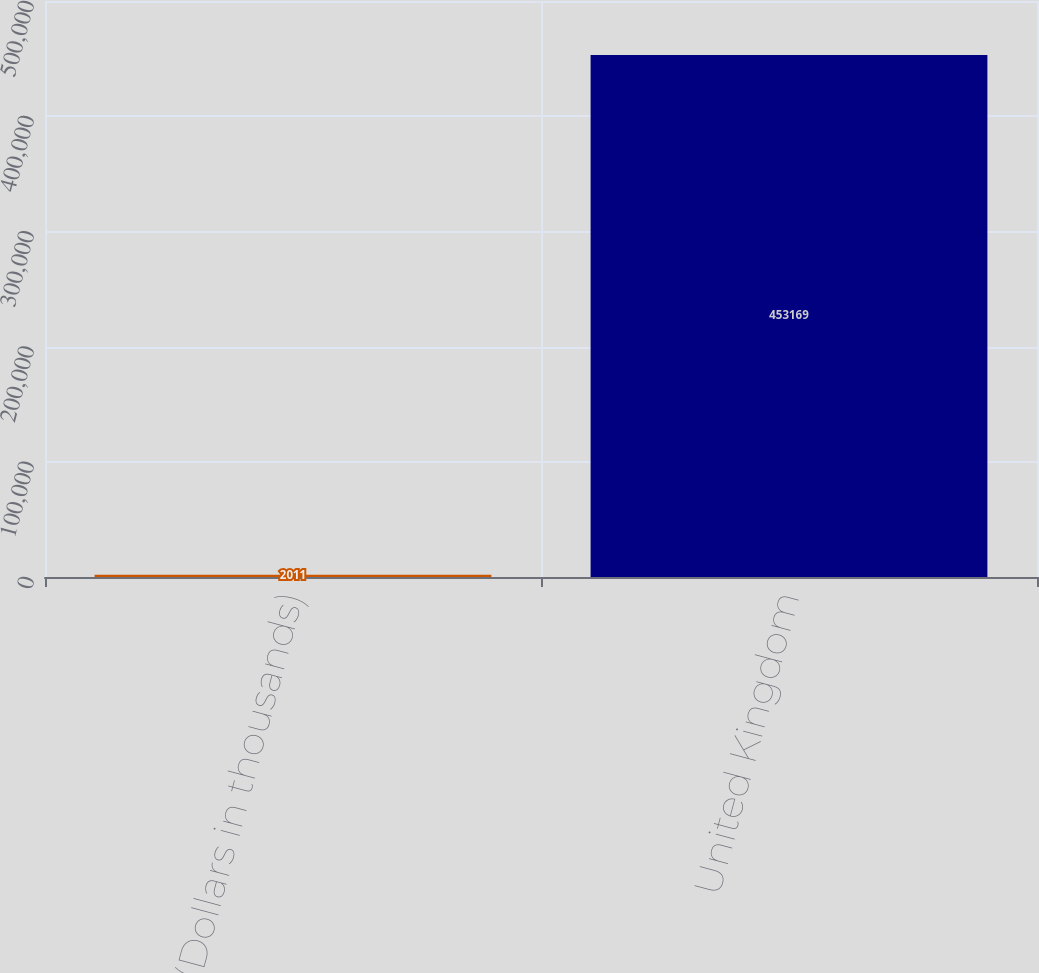<chart> <loc_0><loc_0><loc_500><loc_500><bar_chart><fcel>(Dollars in thousands)<fcel>United Kingdom<nl><fcel>2011<fcel>453169<nl></chart> 